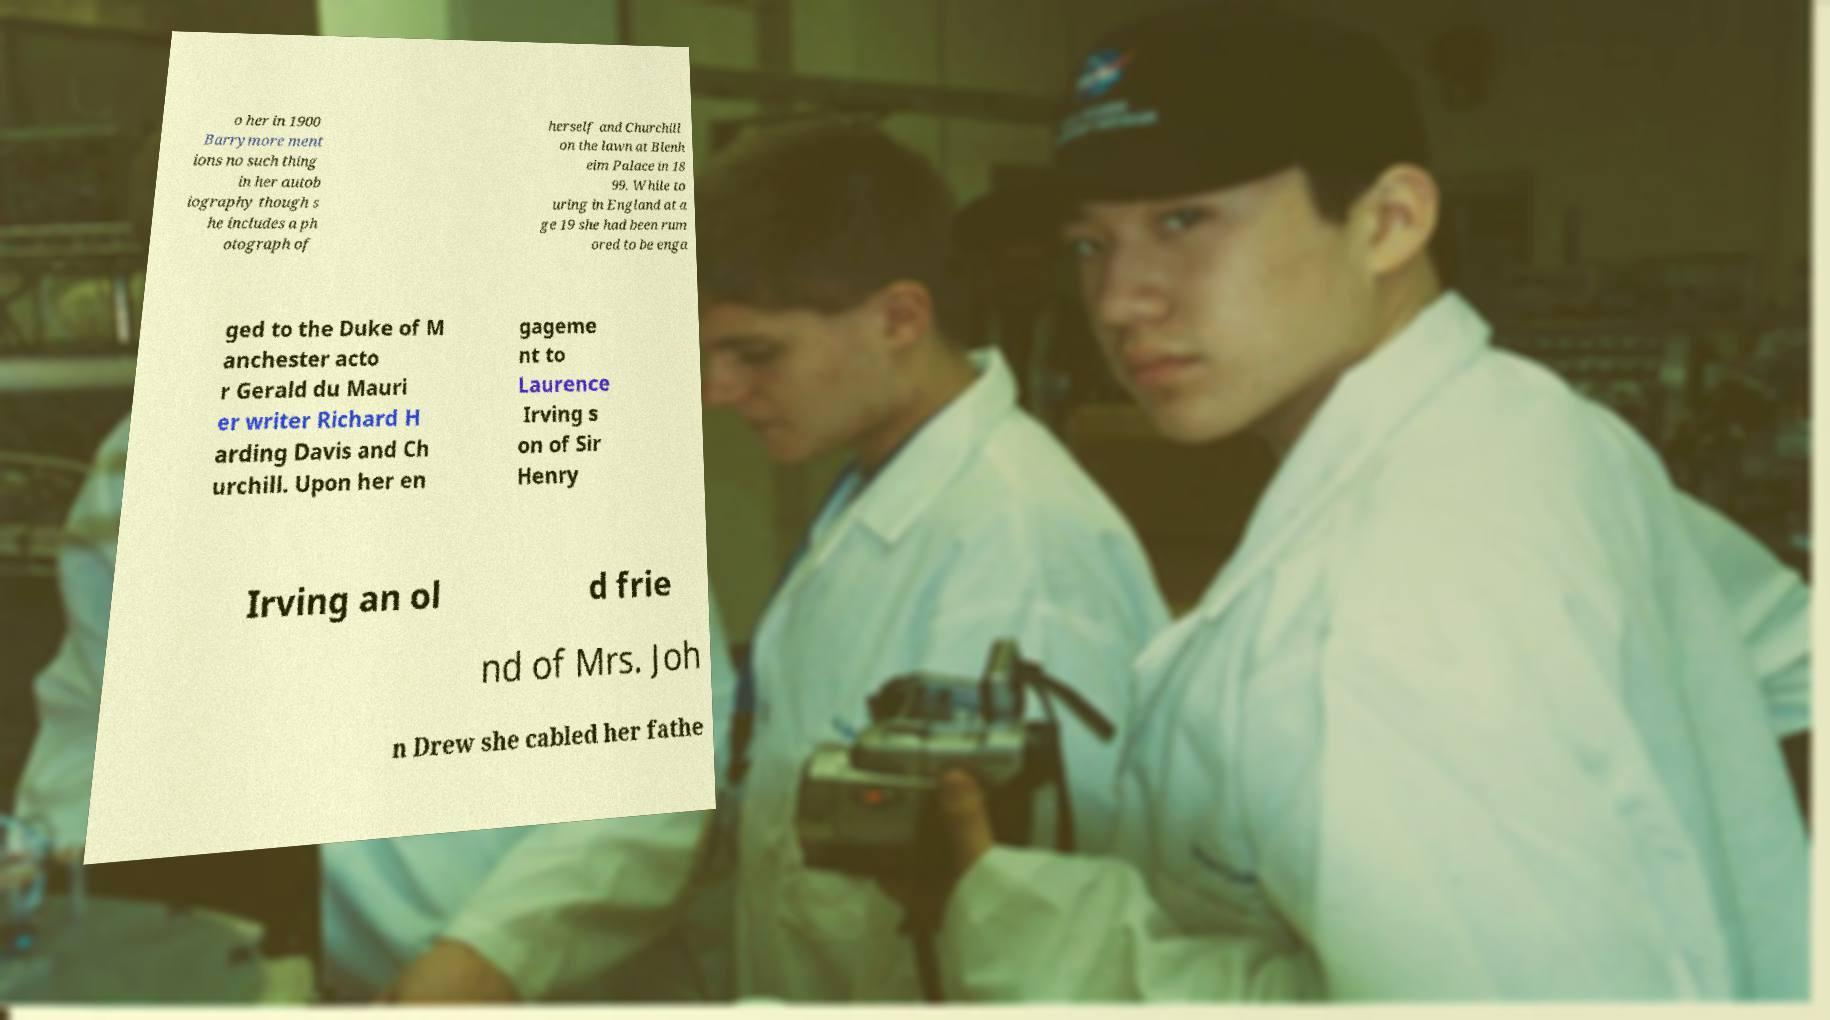I need the written content from this picture converted into text. Can you do that? o her in 1900 Barrymore ment ions no such thing in her autob iography though s he includes a ph otograph of herself and Churchill on the lawn at Blenh eim Palace in 18 99. While to uring in England at a ge 19 she had been rum ored to be enga ged to the Duke of M anchester acto r Gerald du Mauri er writer Richard H arding Davis and Ch urchill. Upon her en gageme nt to Laurence Irving s on of Sir Henry Irving an ol d frie nd of Mrs. Joh n Drew she cabled her fathe 